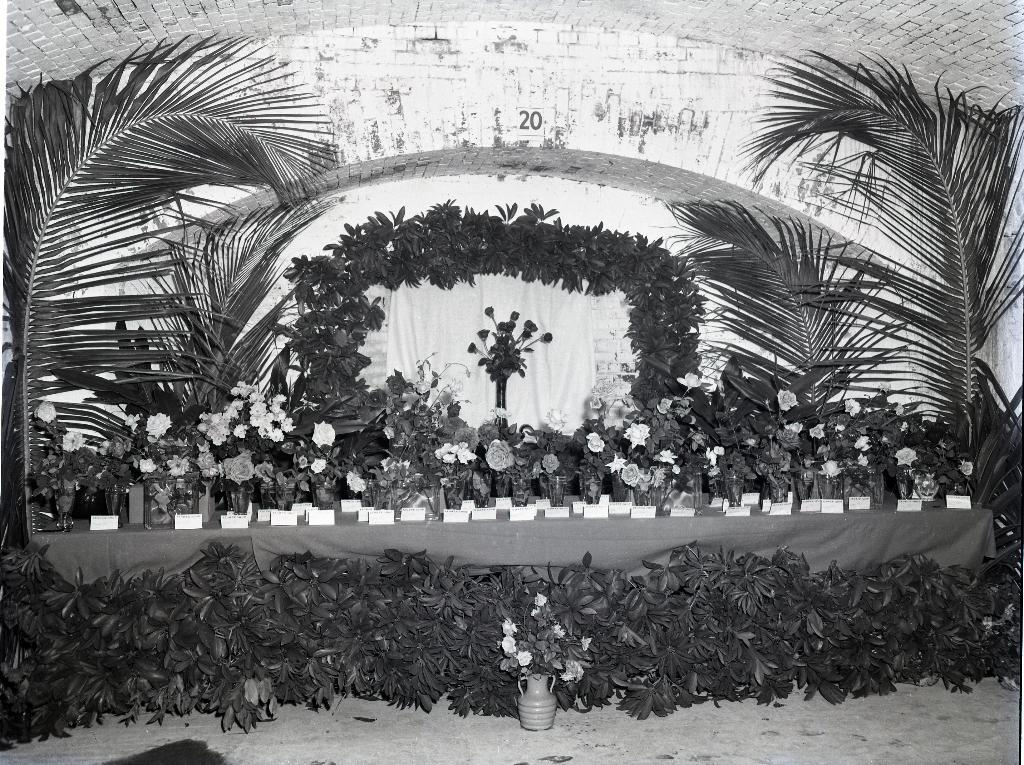What is the color scheme of the image? The image is black and white. What type of vegetation can be seen in the image? There are plants and flowers in the image. What are the flower vases used for in the image? The flower vases are used to hold flowers in the image. What type of window treatment is present in the image? There is a curtain in the image. What type of structure is visible in the image? There is a wall in the image. What is the income of the giraffe in the image? There is no giraffe present in the image, so it is not possible to determine its income. 